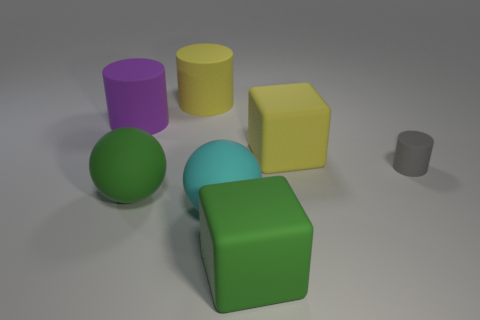Subtract all gray matte cylinders. How many cylinders are left? 2 Add 2 big rubber things. How many objects exist? 9 Subtract all yellow cylinders. How many cylinders are left? 2 Subtract all green cylinders. Subtract all brown blocks. How many cylinders are left? 3 Subtract all blocks. How many objects are left? 5 Subtract all green cubes. Subtract all big matte blocks. How many objects are left? 4 Add 3 rubber things. How many rubber things are left? 10 Add 4 large rubber balls. How many large rubber balls exist? 6 Subtract 0 gray cubes. How many objects are left? 7 